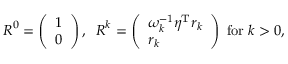<formula> <loc_0><loc_0><loc_500><loc_500>\begin{array} { r } { \boldsymbol R ^ { 0 } = \left ( \begin{array} { l } { 1 } \\ { 0 } \end{array} \right ) , \, \boldsymbol R ^ { k } = \left ( \begin{array} { l } { \omega _ { k } ^ { - 1 } \eta ^ { T } r _ { k } } \\ { r _ { k } } \end{array} \right ) \, f o r \, k > 0 , } \end{array}</formula> 